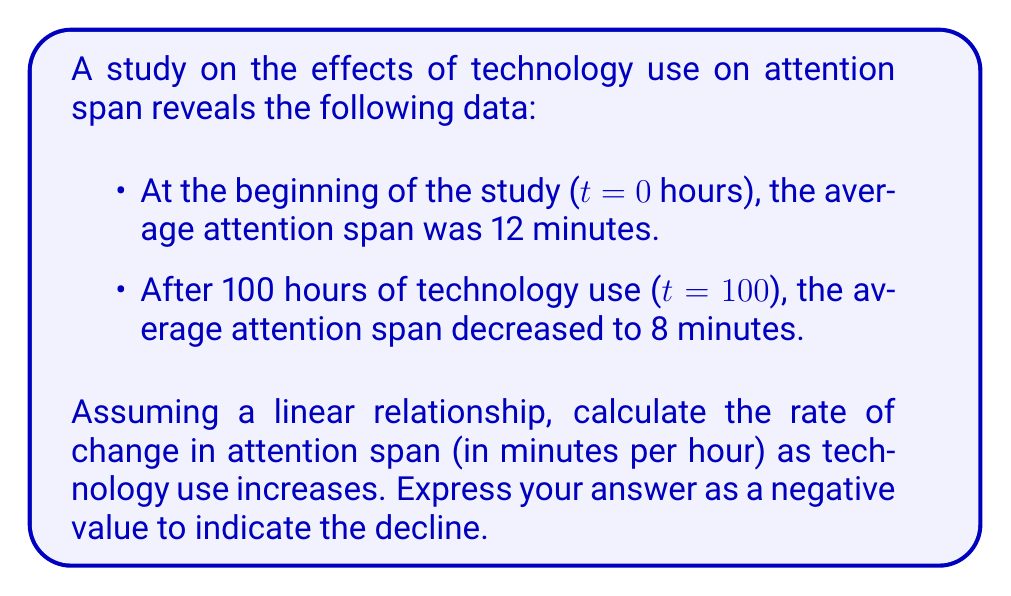Can you solve this math problem? To solve this problem, we'll use the slope formula, which represents the rate of change:

$$ \text{Rate of change} = \frac{\text{Change in y}}{\text{Change in x}} = \frac{y_2 - y_1}{x_2 - x_1} $$

Where:
$y$ represents the attention span in minutes
$x$ represents the time of technology use in hours

Given:
$x_1 = 0$ hours, $y_1 = 12$ minutes
$x_2 = 100$ hours, $y_2 = 8$ minutes

Let's plug these values into the formula:

$$ \text{Rate of change} = \frac{8 - 12}{100 - 0} = \frac{-4}{100} = -0.04 $$

The negative sign indicates a decrease in attention span as technology use increases.

To express this as minutes per hour, we keep the result as is: -0.04 minutes per hour.
Answer: The rate of change in attention span is -0.04 minutes per hour of technology use. 